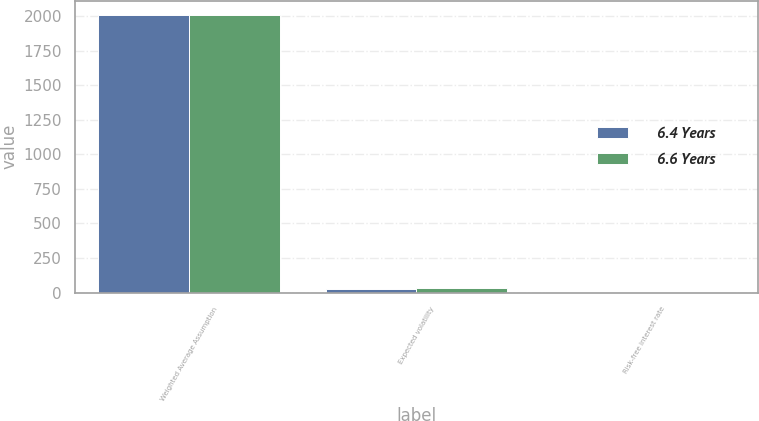Convert chart to OTSL. <chart><loc_0><loc_0><loc_500><loc_500><stacked_bar_chart><ecel><fcel>Weighted Average Assumption<fcel>Expected volatility<fcel>Risk-free interest rate<nl><fcel>6.4 Years<fcel>2008<fcel>26.7<fcel>2.98<nl><fcel>6.6 Years<fcel>2009<fcel>32.1<fcel>2.64<nl></chart> 